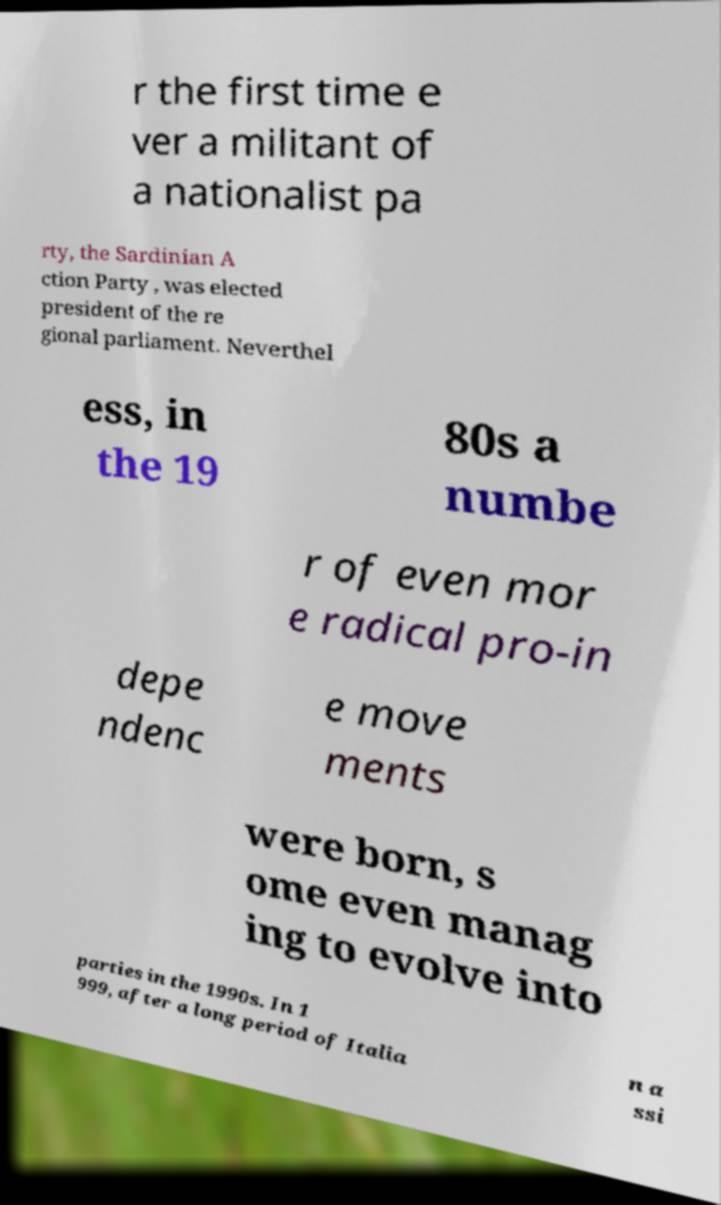Please identify and transcribe the text found in this image. r the first time e ver a militant of a nationalist pa rty, the Sardinian A ction Party , was elected president of the re gional parliament. Neverthel ess, in the 19 80s a numbe r of even mor e radical pro-in depe ndenc e move ments were born, s ome even manag ing to evolve into parties in the 1990s. In 1 999, after a long period of Italia n a ssi 